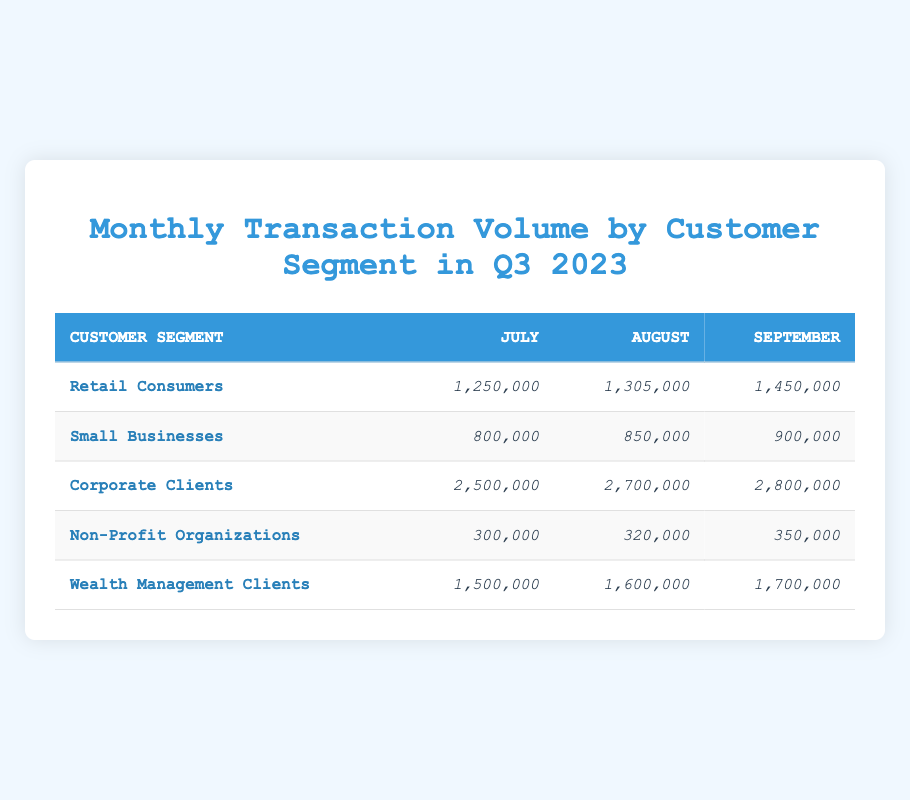What was the transaction volume for Corporate Clients in August 2023? The table shows the transaction volume for Corporate Clients in August, which is clearly listed as 2,700,000.
Answer: 2,700,000 Which customer segment had the highest total transaction volume across all three months? By summing the transaction volumes for each segment: Retail Consumers (1,250,000 + 1,305,000 + 1,450,000 = 4,005,000), Small Businesses (800,000 + 850,000 + 900,000 = 2,550,000), Corporate Clients (2,500,000 + 2,700,000 + 2,800,000 = 8,000,000), Non-Profit Organizations (300,000 + 320,000 + 350,000 = 970,000), Wealth Management Clients (1,500,000 + 1,600,000 + 1,700,000 = 4,800,000). The highest total is for Corporate Clients at 8,000,000.
Answer: Corporate Clients Did the transaction volume for Non-Profit Organizations increase every month in Q3 2023? The transaction volumes for Non-Profit Organizations are: July 300,000, August 320,000, and September 350,000. Each month shows an increase, confirming the trend.
Answer: Yes What is the average transaction volume for Small Businesses over the quarter? The transaction volumes for Small Businesses are: July 800,000, August 850,000, and September 900,000. Summing these gives 800,000 + 850,000 + 900,000 = 2,550,000. To find the average, we divide by 3, yielding 2,550,000 / 3 = 850,000.
Answer: 850,000 Which customer segment had the lowest transaction volume in July 2023? In July 2023, transaction volumes were: Retail Consumers (1,250,000), Small Businesses (800,000), Corporate Clients (2,500,000), Non-Profit Organizations (300,000), and Wealth Management Clients (1,500,000). The lowest volume is 300,000 for Non-Profit Organizations.
Answer: Non-Profit Organizations What was the overall increase in transaction volume for Wealth Management Clients from July to September? The transaction volumes are 1,500,000 in July and 1,700,000 in September. The increase is calculated as 1,700,000 - 1,500,000 = 200,000.
Answer: 200,000 Which segment averaged more than 1.5 million in transaction volume per month? Average for each segment: Retail Consumers (4,005,000 / 3 = 1,335,000), Small Businesses (2,550,000 / 3 = 850,000), Corporate Clients (8,000,000 / 3 = 2,666,667), Non-Profit Organizations (970,000 / 3 = 323,333), Wealth Management Clients (4,800,000 / 3 = 1,600,000). Corporate Clients and Wealth Management Clients both average above 1.5 million.
Answer: Corporate Clients and Wealth Management Clients How much greater was the total transaction volume for Corporate Clients compared to Retail Consumers over the quarter? Total for Corporate Clients is 8,000,000 and for Retail Consumers is 4,005,000. The difference is 8,000,000 - 4,005,000 = 3,995,000.
Answer: 3,995,000 